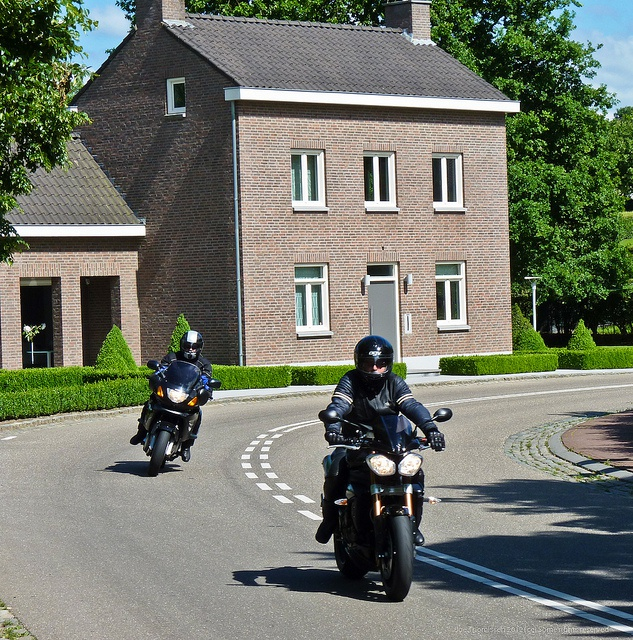Describe the objects in this image and their specific colors. I can see motorcycle in lightgreen, black, gray, white, and navy tones, people in lightgreen, black, gray, navy, and blue tones, motorcycle in lightgreen, black, navy, gray, and white tones, and people in lightgreen, black, gray, navy, and white tones in this image. 